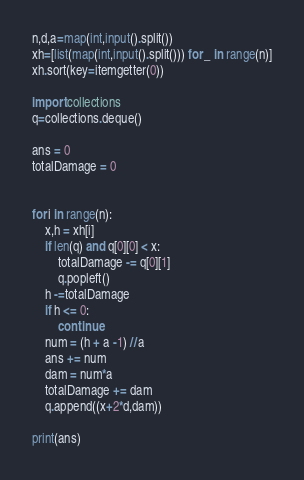<code> <loc_0><loc_0><loc_500><loc_500><_Python_>n,d,a=map(int,input().split())
xh=[list(map(int,input().split())) for _ in range(n)]
xh.sort(key=itemgetter(0))

import collections
q=collections.deque()

ans = 0
totalDamage = 0


for i in range(n):
    x,h = xh[i]
    if len(q) and q[0][0] < x:
        totalDamage -= q[0][1]
        q.popleft()
    h -=totalDamage
    if h <= 0:
        continue
    num = (h + a -1) //a
    ans += num
    dam = num*a
    totalDamage += dam
    q.append((x+2*d,dam))

print(ans)</code> 